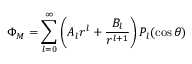Convert formula to latex. <formula><loc_0><loc_0><loc_500><loc_500>\Phi _ { M } = \sum _ { l = 0 } ^ { \infty } \left ( A _ { l } r ^ { l } + { \frac { B _ { l } } { r ^ { l + 1 } } } \right ) P _ { l } ( \cos \theta )</formula> 